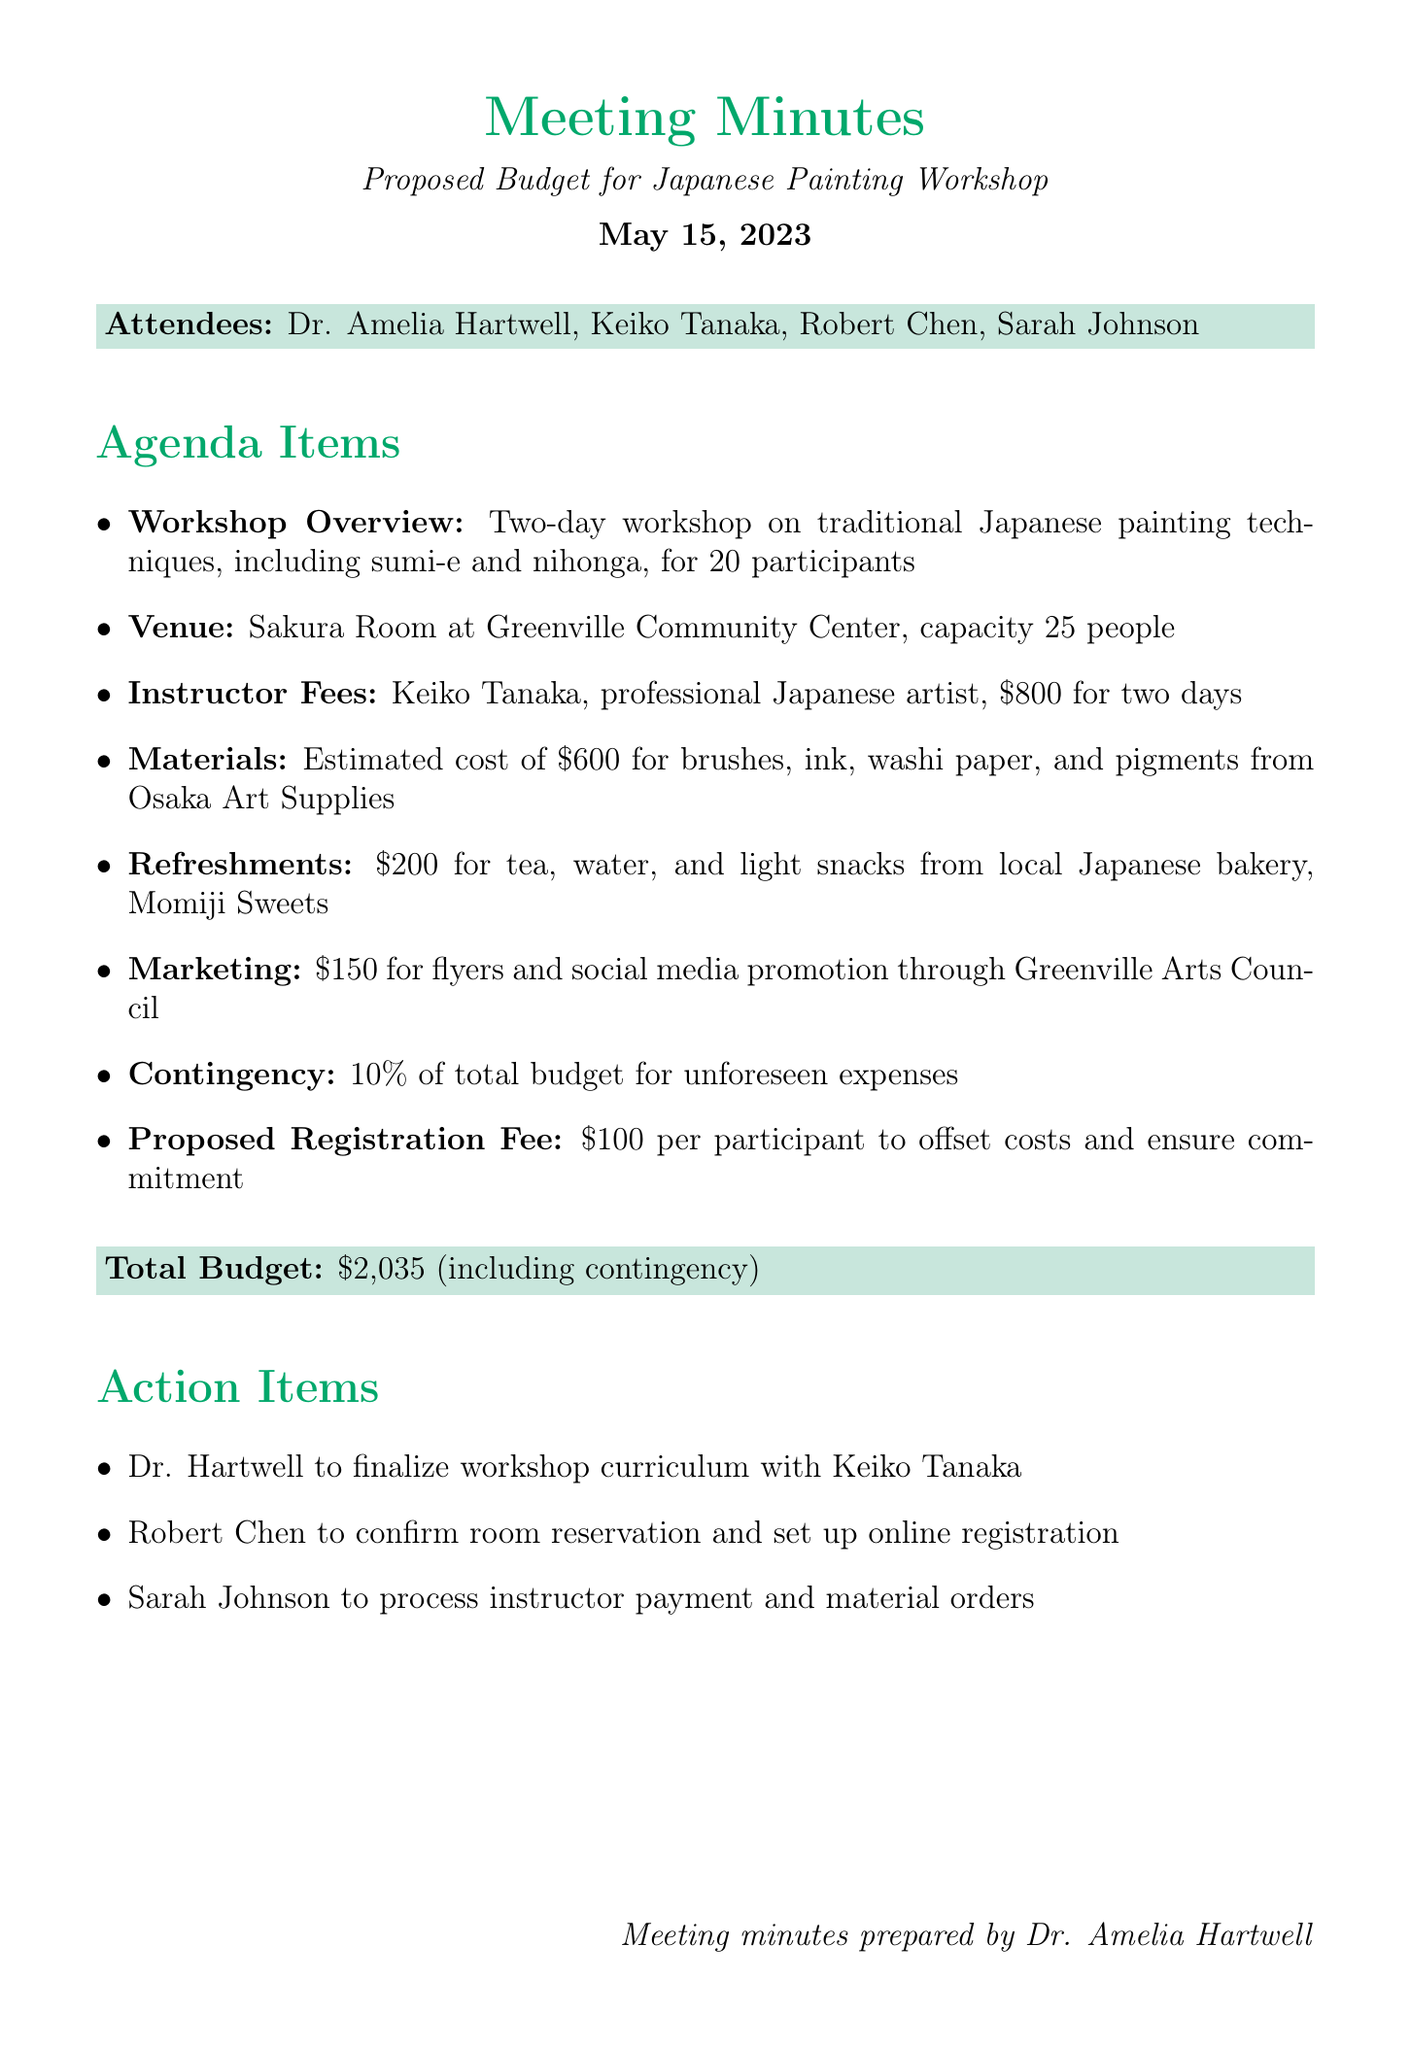What is the date of the meeting? The date of the meeting is explicitly mentioned in the document.
Answer: May 15, 2023 Who is the main instructor for the workshop? The meeting minutes list the instructor and their details clearly.
Answer: Keiko Tanaka What is the proposed registration fee per participant? The registration fee is clearly stated in the budget section of the minutes.
Answer: $100 What is the total budget for the workshop? The total budget is summarized in the meeting minutes, including all costs.
Answer: $2,035 (including contingency) How many participants will the workshop accommodate? The workshop overview specifies the number of participants allowed.
Answer: 20 participants What percentage of the budget is allocated for contingency expenses? The contingency is described as a percentage of the total budget in the document.
Answer: 10% What type of painting techniques will the workshop focus on? The workshop overview provides details about the specific painting techniques that will be taught.
Answer: sumi-e and nihonga Who is responsible for confirming the room reservation? The action items list the person assigned to confirm the reservation.
Answer: Robert Chen 